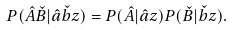<formula> <loc_0><loc_0><loc_500><loc_500>P ( \hat { A } \check { B } | \hat { a } \check { b } z ) = P ( \hat { A } | \hat { a } z ) P ( \check { B } | \check { b } z ) .</formula> 